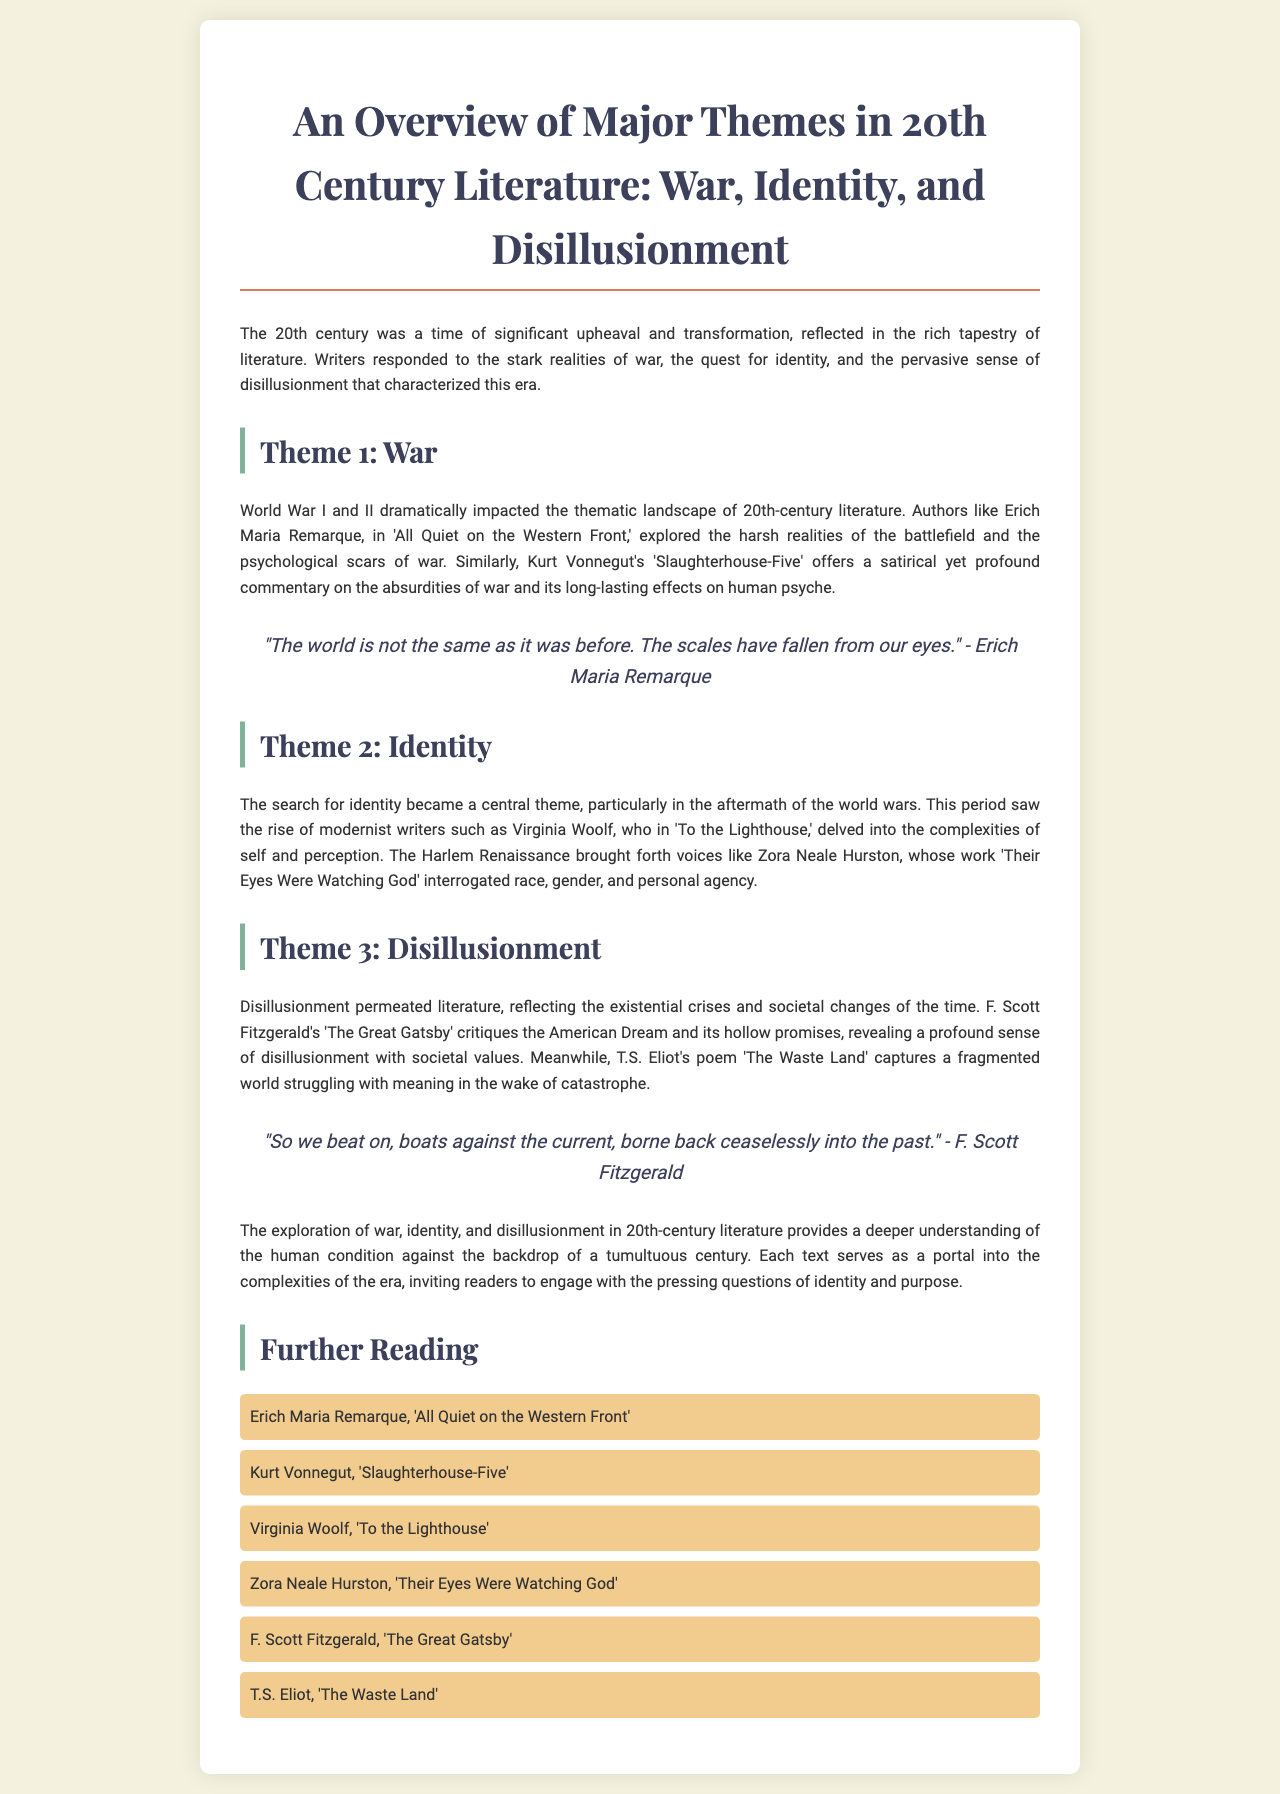What is the title of the brochure? The title of the brochure is found at the top of the document, stating the main subject matter.
Answer: An Overview of Major Themes in 20th Century Literature: War, Identity, and Disillusionment Who wrote 'All Quiet on the Western Front'? The author of 'All Quiet on the Western Front' is mentioned in the section discussing the theme of war.
Answer: Erich Maria Remarque What is one key theme discussed in the brochure? The brochure outlines several themes, listed in the main body.
Answer: War Which literary work critiques the American Dream? The specific text that addresses this theme is mentioned in the section about disillusionment.
Answer: The Great Gatsby Who is a modernist writer mentioned in the identity theme? The document highlights modernist writers in the context of identity.
Answer: Virginia Woolf What genre of literature is highlighted in the Harlem Renaissance? The brochure discusses writers associated with a specific cultural movement.
Answer: Voices Name one work by T.S. Eliot discussed in the brochure. The document explicitly lists T.S. Eliot's work in the section regarding disillusionment.
Answer: The Waste Land Which war influenced 20th-century literature according to the document? The brochure explains the significant wars that impacted the literature of this century.
Answer: World War I and II What is the format of the further reading section? The brochure includes a list that provides additional texts for exploration at the end.
Answer: A list of literary works 